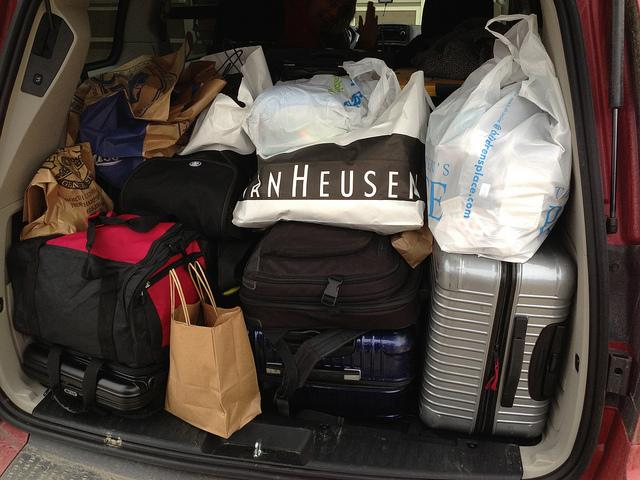What most likely happened before this? Please explain your reasoning. shopping. Shopping bags are displayed. 